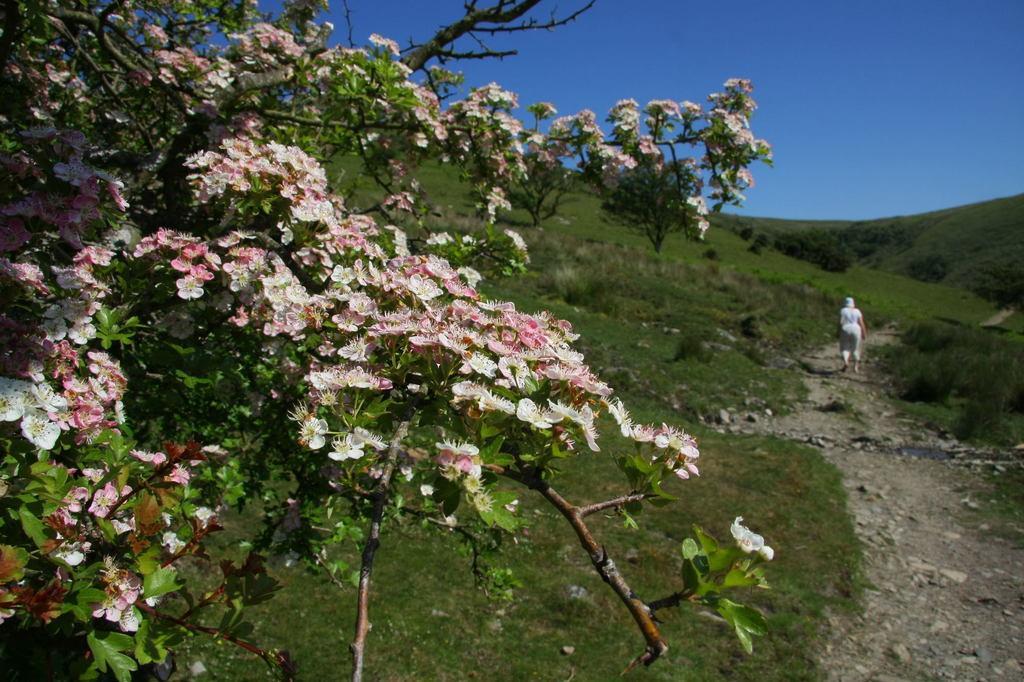Please provide a concise description of this image. In this picture we can see flowers, leaves, stems and land covered with grass. On the right side, we can see a person walking on the ground. The sky is blue. 